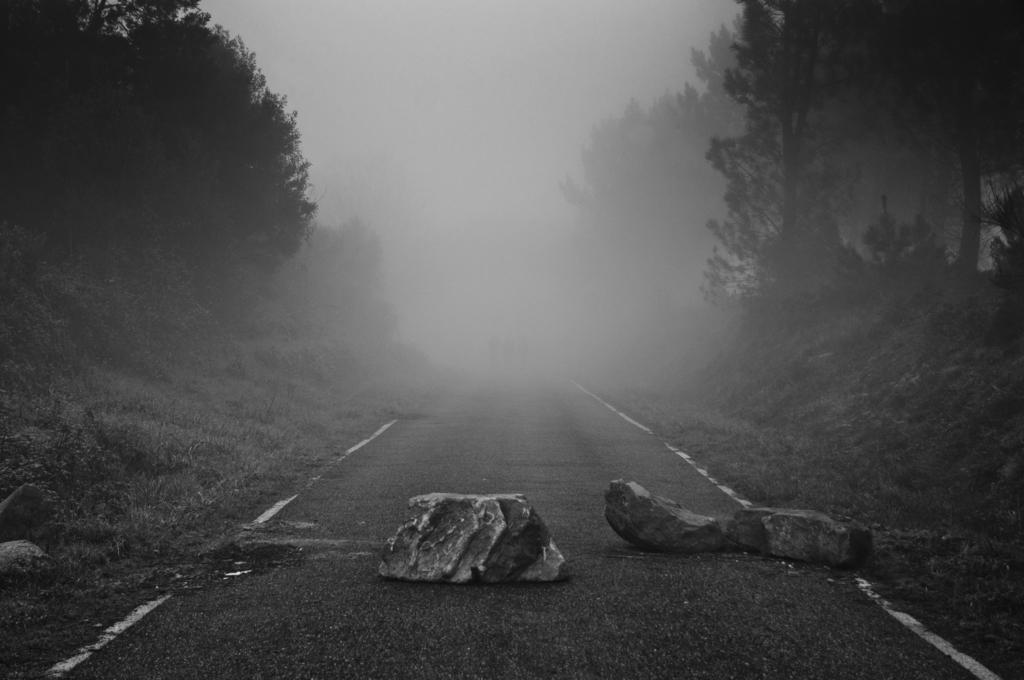In one or two sentences, can you explain what this image depicts? In this image in the front there are stones on the road. In the background there are trees and there is fog. 